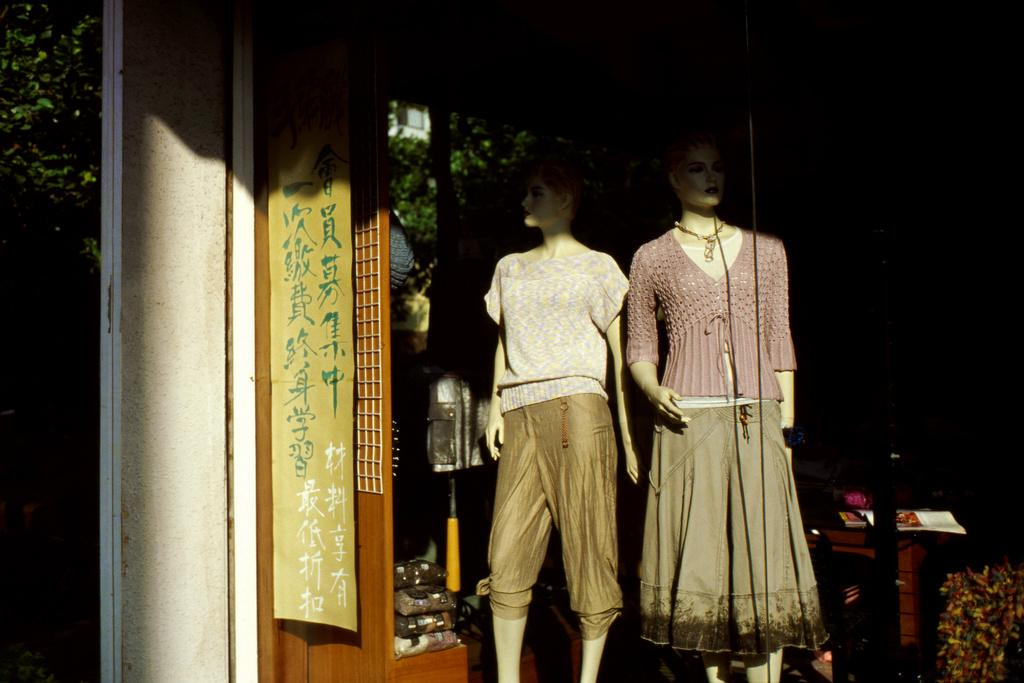What are the main subjects in the center of the image? There are two mannequins in the center of the image. What other structure can be seen in the image? There is a pole or a pillar in the image. What else is present in the image besides the mannequins and the pole? There are other objects in the image. What can be seen in the background of the image? Trees and plants are visible in the background of the image. What is hanging in the image with some text? There is a banner hanging in the image with some text. What degree does the chair in the image have? There is no chair present in the image, so it does not have a degree. What reason does the mannequin have for standing next to the pole? The image does not provide any information about the mannequins' reasons for standing next to the pole, as they are inanimate objects. 